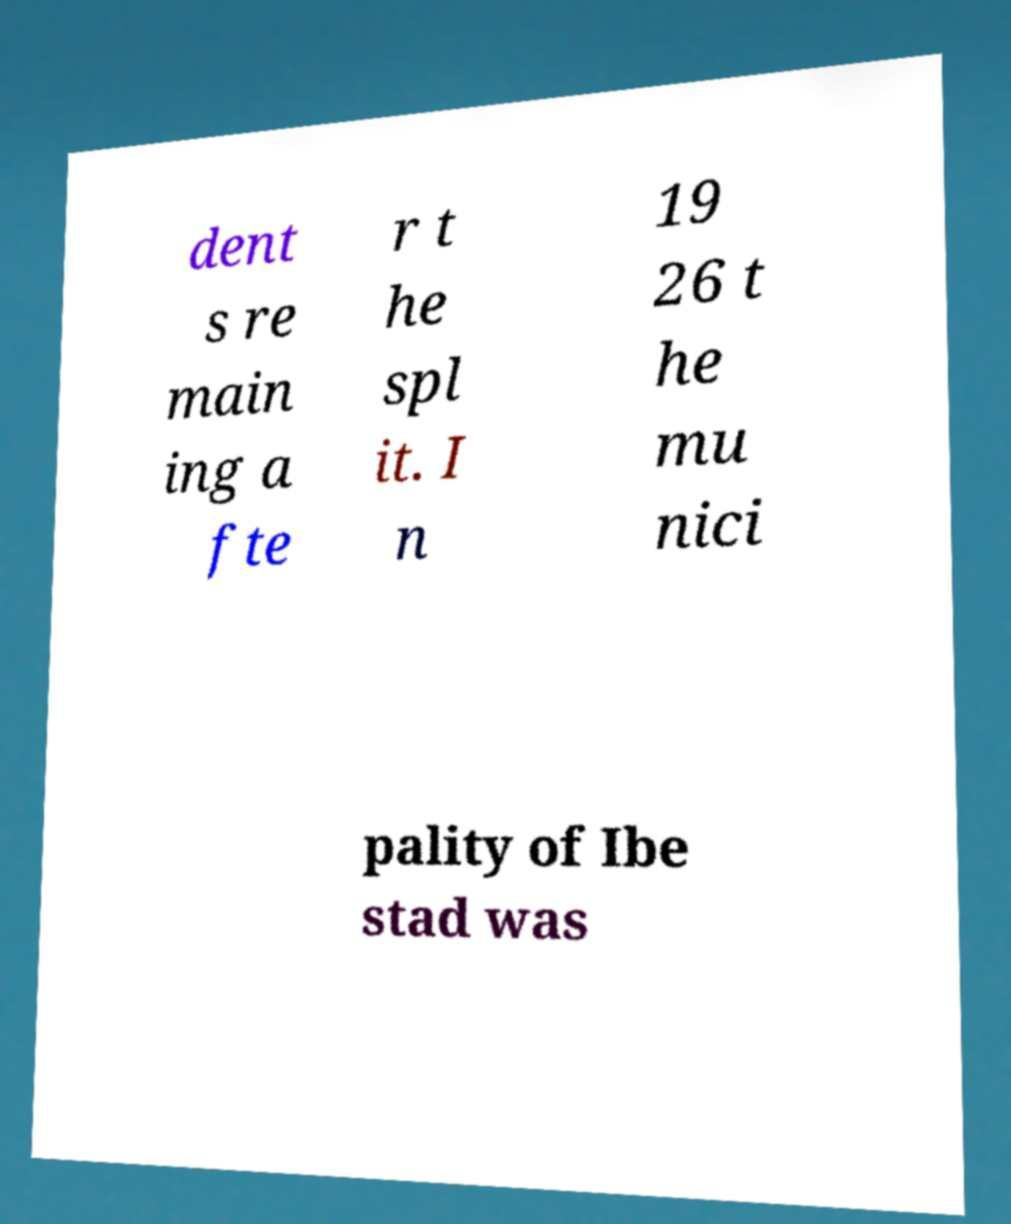What messages or text are displayed in this image? I need them in a readable, typed format. dent s re main ing a fte r t he spl it. I n 19 26 t he mu nici pality of Ibe stad was 